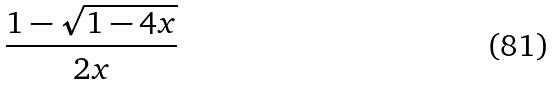<formula> <loc_0><loc_0><loc_500><loc_500>\frac { 1 - \sqrt { 1 - 4 x } } { 2 x }</formula> 